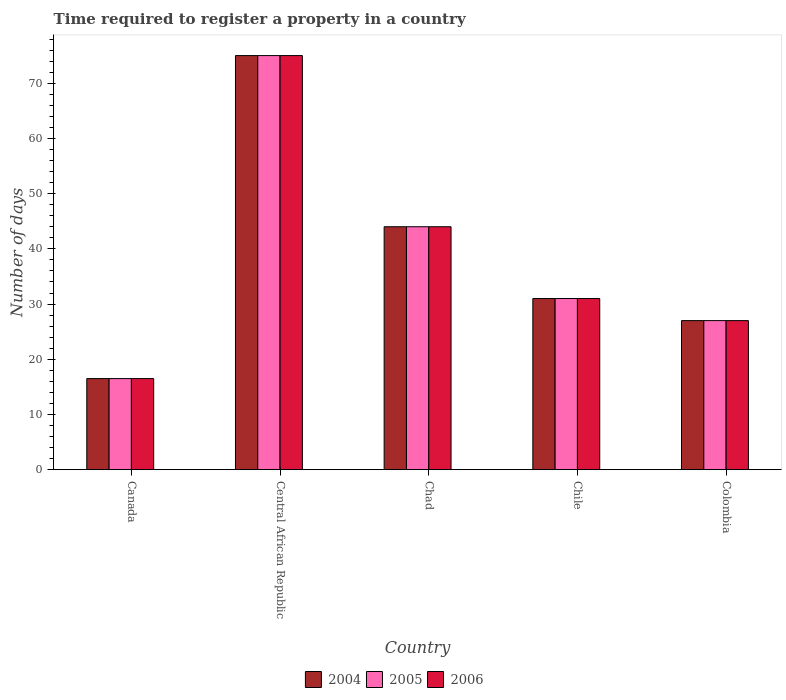How many different coloured bars are there?
Keep it short and to the point. 3. In how many cases, is the number of bars for a given country not equal to the number of legend labels?
Provide a short and direct response. 0. What is the number of days required to register a property in 2006 in Chad?
Offer a terse response. 44. In which country was the number of days required to register a property in 2006 maximum?
Offer a terse response. Central African Republic. In which country was the number of days required to register a property in 2006 minimum?
Your response must be concise. Canada. What is the total number of days required to register a property in 2005 in the graph?
Your answer should be compact. 193.5. What is the difference between the number of days required to register a property in 2006 in Canada and that in Colombia?
Give a very brief answer. -10.5. What is the difference between the number of days required to register a property in 2004 in Chile and the number of days required to register a property in 2005 in Central African Republic?
Offer a terse response. -44. What is the average number of days required to register a property in 2006 per country?
Your answer should be compact. 38.7. What is the difference between the number of days required to register a property of/in 2005 and number of days required to register a property of/in 2006 in Colombia?
Your response must be concise. 0. In how many countries, is the number of days required to register a property in 2004 greater than 20 days?
Give a very brief answer. 4. What is the ratio of the number of days required to register a property in 2004 in Canada to that in Chile?
Make the answer very short. 0.53. Is the number of days required to register a property in 2006 in Chad less than that in Chile?
Make the answer very short. No. What is the difference between the highest and the second highest number of days required to register a property in 2004?
Your answer should be very brief. 31. What is the difference between the highest and the lowest number of days required to register a property in 2005?
Give a very brief answer. 58.5. In how many countries, is the number of days required to register a property in 2004 greater than the average number of days required to register a property in 2004 taken over all countries?
Your answer should be very brief. 2. What does the 1st bar from the right in Colombia represents?
Give a very brief answer. 2006. Is it the case that in every country, the sum of the number of days required to register a property in 2005 and number of days required to register a property in 2004 is greater than the number of days required to register a property in 2006?
Provide a short and direct response. Yes. How many bars are there?
Offer a very short reply. 15. Are all the bars in the graph horizontal?
Your response must be concise. No. How many countries are there in the graph?
Make the answer very short. 5. What is the difference between two consecutive major ticks on the Y-axis?
Offer a terse response. 10. Does the graph contain any zero values?
Offer a terse response. No. Does the graph contain grids?
Ensure brevity in your answer.  No. How are the legend labels stacked?
Make the answer very short. Horizontal. What is the title of the graph?
Give a very brief answer. Time required to register a property in a country. What is the label or title of the X-axis?
Provide a succinct answer. Country. What is the label or title of the Y-axis?
Ensure brevity in your answer.  Number of days. What is the Number of days of 2006 in Canada?
Make the answer very short. 16.5. What is the Number of days of 2006 in Central African Republic?
Offer a very short reply. 75. What is the Number of days of 2006 in Chad?
Provide a short and direct response. 44. What is the Number of days of 2006 in Chile?
Ensure brevity in your answer.  31. What is the Number of days in 2005 in Colombia?
Give a very brief answer. 27. What is the Number of days of 2006 in Colombia?
Ensure brevity in your answer.  27. Across all countries, what is the maximum Number of days of 2004?
Offer a very short reply. 75. Across all countries, what is the maximum Number of days in 2006?
Provide a succinct answer. 75. Across all countries, what is the minimum Number of days of 2005?
Offer a terse response. 16.5. What is the total Number of days of 2004 in the graph?
Offer a terse response. 193.5. What is the total Number of days in 2005 in the graph?
Offer a very short reply. 193.5. What is the total Number of days of 2006 in the graph?
Your answer should be very brief. 193.5. What is the difference between the Number of days of 2004 in Canada and that in Central African Republic?
Your answer should be compact. -58.5. What is the difference between the Number of days of 2005 in Canada and that in Central African Republic?
Make the answer very short. -58.5. What is the difference between the Number of days of 2006 in Canada and that in Central African Republic?
Make the answer very short. -58.5. What is the difference between the Number of days of 2004 in Canada and that in Chad?
Your answer should be compact. -27.5. What is the difference between the Number of days of 2005 in Canada and that in Chad?
Provide a succinct answer. -27.5. What is the difference between the Number of days in 2006 in Canada and that in Chad?
Your response must be concise. -27.5. What is the difference between the Number of days in 2006 in Canada and that in Chile?
Your answer should be compact. -14.5. What is the difference between the Number of days in 2005 in Canada and that in Colombia?
Ensure brevity in your answer.  -10.5. What is the difference between the Number of days of 2006 in Canada and that in Colombia?
Keep it short and to the point. -10.5. What is the difference between the Number of days in 2004 in Central African Republic and that in Chad?
Offer a very short reply. 31. What is the difference between the Number of days in 2005 in Central African Republic and that in Chad?
Provide a short and direct response. 31. What is the difference between the Number of days in 2006 in Central African Republic and that in Chad?
Provide a succinct answer. 31. What is the difference between the Number of days of 2004 in Central African Republic and that in Chile?
Offer a very short reply. 44. What is the difference between the Number of days of 2006 in Central African Republic and that in Chile?
Provide a succinct answer. 44. What is the difference between the Number of days in 2004 in Central African Republic and that in Colombia?
Your response must be concise. 48. What is the difference between the Number of days of 2006 in Central African Republic and that in Colombia?
Offer a terse response. 48. What is the difference between the Number of days in 2004 in Chad and that in Chile?
Your answer should be compact. 13. What is the difference between the Number of days of 2006 in Chad and that in Colombia?
Keep it short and to the point. 17. What is the difference between the Number of days of 2004 in Canada and the Number of days of 2005 in Central African Republic?
Provide a short and direct response. -58.5. What is the difference between the Number of days of 2004 in Canada and the Number of days of 2006 in Central African Republic?
Your response must be concise. -58.5. What is the difference between the Number of days in 2005 in Canada and the Number of days in 2006 in Central African Republic?
Provide a short and direct response. -58.5. What is the difference between the Number of days of 2004 in Canada and the Number of days of 2005 in Chad?
Make the answer very short. -27.5. What is the difference between the Number of days in 2004 in Canada and the Number of days in 2006 in Chad?
Provide a short and direct response. -27.5. What is the difference between the Number of days of 2005 in Canada and the Number of days of 2006 in Chad?
Ensure brevity in your answer.  -27.5. What is the difference between the Number of days in 2004 in Canada and the Number of days in 2005 in Chile?
Provide a succinct answer. -14.5. What is the difference between the Number of days of 2005 in Canada and the Number of days of 2006 in Chile?
Provide a short and direct response. -14.5. What is the difference between the Number of days in 2004 in Canada and the Number of days in 2005 in Colombia?
Your answer should be compact. -10.5. What is the difference between the Number of days of 2004 in Canada and the Number of days of 2006 in Colombia?
Keep it short and to the point. -10.5. What is the difference between the Number of days of 2004 in Central African Republic and the Number of days of 2005 in Chad?
Your answer should be compact. 31. What is the difference between the Number of days of 2004 in Central African Republic and the Number of days of 2006 in Chad?
Offer a very short reply. 31. What is the difference between the Number of days in 2004 in Central African Republic and the Number of days in 2005 in Chile?
Your response must be concise. 44. What is the difference between the Number of days of 2005 in Central African Republic and the Number of days of 2006 in Chile?
Your answer should be very brief. 44. What is the difference between the Number of days in 2004 in Central African Republic and the Number of days in 2005 in Colombia?
Make the answer very short. 48. What is the difference between the Number of days in 2004 in Central African Republic and the Number of days in 2006 in Colombia?
Keep it short and to the point. 48. What is the difference between the Number of days of 2005 in Central African Republic and the Number of days of 2006 in Colombia?
Make the answer very short. 48. What is the difference between the Number of days of 2004 in Chad and the Number of days of 2005 in Chile?
Provide a succinct answer. 13. What is the difference between the Number of days of 2004 in Chad and the Number of days of 2006 in Chile?
Give a very brief answer. 13. What is the difference between the Number of days of 2005 in Chad and the Number of days of 2006 in Chile?
Provide a succinct answer. 13. What is the difference between the Number of days of 2004 in Chad and the Number of days of 2005 in Colombia?
Provide a short and direct response. 17. What is the difference between the Number of days in 2004 in Chad and the Number of days in 2006 in Colombia?
Offer a terse response. 17. What is the difference between the Number of days of 2004 in Chile and the Number of days of 2006 in Colombia?
Offer a very short reply. 4. What is the average Number of days of 2004 per country?
Offer a terse response. 38.7. What is the average Number of days of 2005 per country?
Provide a succinct answer. 38.7. What is the average Number of days in 2006 per country?
Your response must be concise. 38.7. What is the difference between the Number of days in 2004 and Number of days in 2005 in Canada?
Ensure brevity in your answer.  0. What is the difference between the Number of days in 2004 and Number of days in 2005 in Central African Republic?
Provide a succinct answer. 0. What is the difference between the Number of days of 2004 and Number of days of 2006 in Central African Republic?
Make the answer very short. 0. What is the difference between the Number of days of 2005 and Number of days of 2006 in Central African Republic?
Your answer should be very brief. 0. What is the difference between the Number of days in 2004 and Number of days in 2006 in Chad?
Offer a very short reply. 0. What is the difference between the Number of days of 2005 and Number of days of 2006 in Chad?
Ensure brevity in your answer.  0. What is the difference between the Number of days of 2004 and Number of days of 2005 in Chile?
Offer a very short reply. 0. What is the difference between the Number of days in 2004 and Number of days in 2006 in Chile?
Provide a short and direct response. 0. What is the ratio of the Number of days of 2004 in Canada to that in Central African Republic?
Your answer should be very brief. 0.22. What is the ratio of the Number of days in 2005 in Canada to that in Central African Republic?
Make the answer very short. 0.22. What is the ratio of the Number of days of 2006 in Canada to that in Central African Republic?
Ensure brevity in your answer.  0.22. What is the ratio of the Number of days of 2005 in Canada to that in Chad?
Make the answer very short. 0.38. What is the ratio of the Number of days in 2004 in Canada to that in Chile?
Make the answer very short. 0.53. What is the ratio of the Number of days of 2005 in Canada to that in Chile?
Offer a terse response. 0.53. What is the ratio of the Number of days in 2006 in Canada to that in Chile?
Ensure brevity in your answer.  0.53. What is the ratio of the Number of days in 2004 in Canada to that in Colombia?
Offer a very short reply. 0.61. What is the ratio of the Number of days in 2005 in Canada to that in Colombia?
Your answer should be very brief. 0.61. What is the ratio of the Number of days in 2006 in Canada to that in Colombia?
Make the answer very short. 0.61. What is the ratio of the Number of days of 2004 in Central African Republic to that in Chad?
Make the answer very short. 1.7. What is the ratio of the Number of days in 2005 in Central African Republic to that in Chad?
Your answer should be very brief. 1.7. What is the ratio of the Number of days in 2006 in Central African Republic to that in Chad?
Keep it short and to the point. 1.7. What is the ratio of the Number of days of 2004 in Central African Republic to that in Chile?
Give a very brief answer. 2.42. What is the ratio of the Number of days in 2005 in Central African Republic to that in Chile?
Ensure brevity in your answer.  2.42. What is the ratio of the Number of days of 2006 in Central African Republic to that in Chile?
Offer a terse response. 2.42. What is the ratio of the Number of days in 2004 in Central African Republic to that in Colombia?
Provide a short and direct response. 2.78. What is the ratio of the Number of days of 2005 in Central African Republic to that in Colombia?
Give a very brief answer. 2.78. What is the ratio of the Number of days of 2006 in Central African Republic to that in Colombia?
Your answer should be compact. 2.78. What is the ratio of the Number of days in 2004 in Chad to that in Chile?
Your answer should be very brief. 1.42. What is the ratio of the Number of days of 2005 in Chad to that in Chile?
Keep it short and to the point. 1.42. What is the ratio of the Number of days of 2006 in Chad to that in Chile?
Provide a short and direct response. 1.42. What is the ratio of the Number of days of 2004 in Chad to that in Colombia?
Your answer should be very brief. 1.63. What is the ratio of the Number of days of 2005 in Chad to that in Colombia?
Give a very brief answer. 1.63. What is the ratio of the Number of days in 2006 in Chad to that in Colombia?
Provide a short and direct response. 1.63. What is the ratio of the Number of days of 2004 in Chile to that in Colombia?
Provide a succinct answer. 1.15. What is the ratio of the Number of days in 2005 in Chile to that in Colombia?
Ensure brevity in your answer.  1.15. What is the ratio of the Number of days in 2006 in Chile to that in Colombia?
Your response must be concise. 1.15. What is the difference between the highest and the second highest Number of days of 2005?
Offer a terse response. 31. What is the difference between the highest and the second highest Number of days in 2006?
Offer a terse response. 31. What is the difference between the highest and the lowest Number of days of 2004?
Keep it short and to the point. 58.5. What is the difference between the highest and the lowest Number of days in 2005?
Keep it short and to the point. 58.5. What is the difference between the highest and the lowest Number of days of 2006?
Make the answer very short. 58.5. 